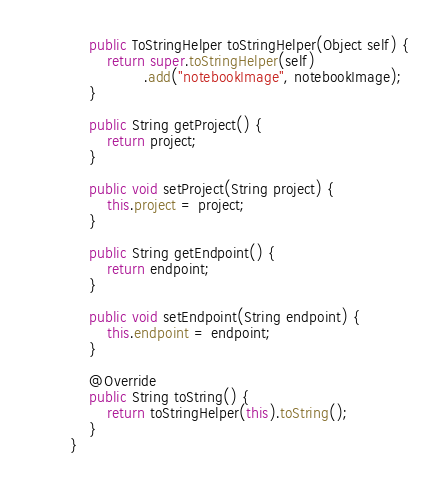<code> <loc_0><loc_0><loc_500><loc_500><_Java_>	public ToStringHelper toStringHelper(Object self) {
		return super.toStringHelper(self)
				.add("notebookImage", notebookImage);
	}

	public String getProject() {
		return project;
	}

	public void setProject(String project) {
		this.project = project;
	}

	public String getEndpoint() {
		return endpoint;
	}

	public void setEndpoint(String endpoint) {
		this.endpoint = endpoint;
	}

	@Override
	public String toString() {
		return toStringHelper(this).toString();
	}
}
</code> 